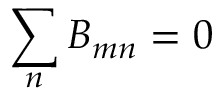<formula> <loc_0><loc_0><loc_500><loc_500>\sum _ { n } B _ { m n } = 0</formula> 